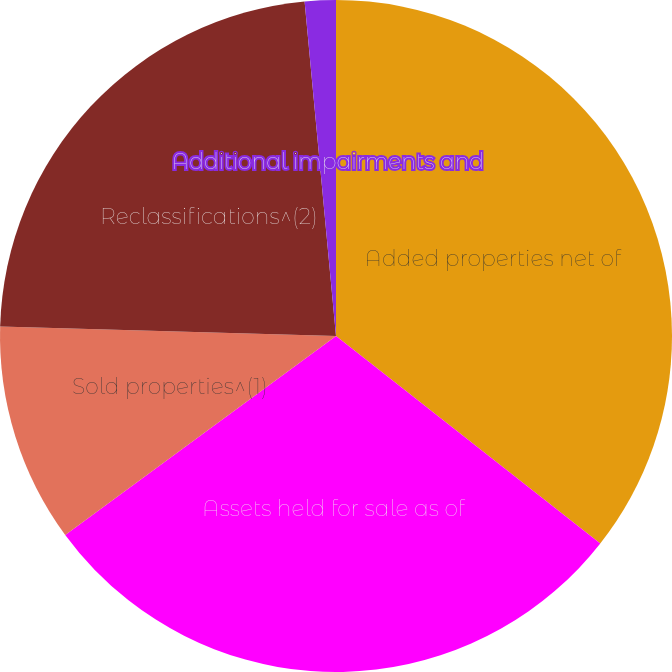Convert chart to OTSL. <chart><loc_0><loc_0><loc_500><loc_500><pie_chart><fcel>Added properties net of<fcel>Assets held for sale as of<fcel>Sold properties^(1)<fcel>Reclassifications^(2)<fcel>Additional impairments and<nl><fcel>35.59%<fcel>29.32%<fcel>10.53%<fcel>23.06%<fcel>1.49%<nl></chart> 